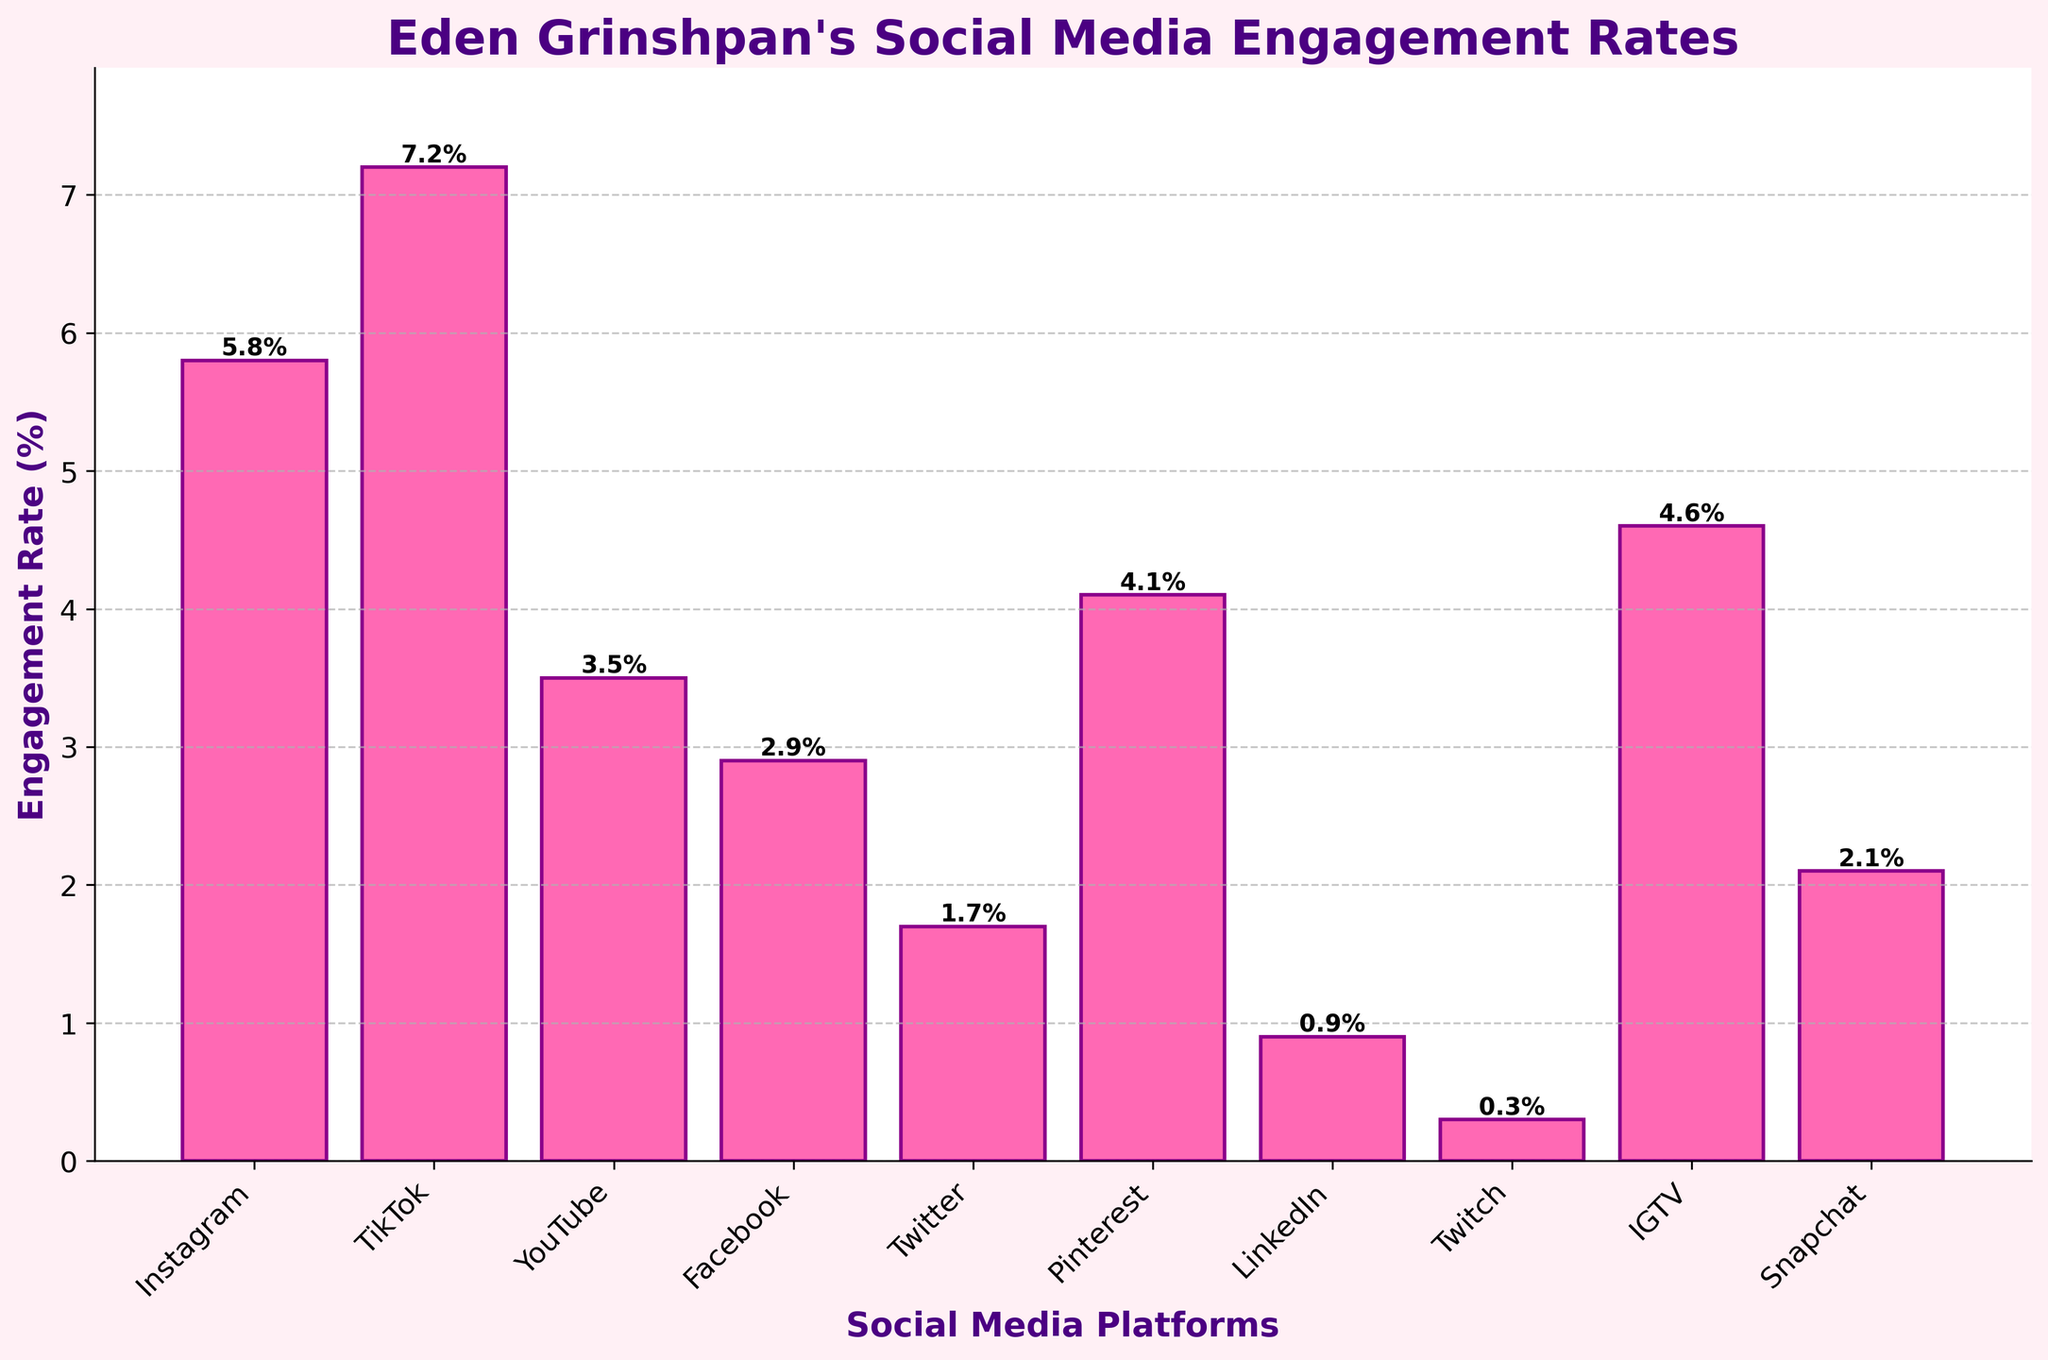What platform has the highest engagement rate? Look at the bar chart and identify the tallest bar, which represents the highest engagement rate.
Answer: TikTok Which platform has the lowest engagement rate? Look at the shortest bar in the bar chart to determine the platform with the lowest engagement rate.
Answer: Twitch What's the difference in engagement rate between Instagram and TikTok? Identify the engagement rates of Instagram (5.8%) and TikTok (7.2%), then subtract the smaller rate from the larger rate: 7.2 - 5.8.
Answer: 1.4% Which platform has a higher engagement rate, YouTube or Facebook? Compare the heights of the bars for YouTube (3.5%) and Facebook (2.9%).
Answer: YouTube What is the average engagement rate across all platforms? Sum all the engagement rates (5.8 + 7.2 + 3.5 + 2.9 + 1.7 + 4.1 + 0.9 + 0.3 + 4.6 + 2.1 = 33.1) and divide by the number of platforms (10): 33.1/10.
Answer: 3.31% Which platform has an engagement rate closest to 4%? Identify the bar closest to the 4% mark. Pinterest (4.1%) is the closest.
Answer: Pinterest Which three platforms have the largest engagement rates? Identify the three tallest bars: TikTok, Instagram, and IGTV with engagement rates of 7.2%, 5.8%, and 4.6% respectively.
Answer: TikTok, Instagram, IGTV How much lower is the engagement rate for LinkedIn compared to Snapchat? Subtract LinkedIn's rate (0.9%) from Snapchat's rate (2.1%): 2.1 - 0.9.
Answer: 1.2% How many platforms have an engagement rate above 4%? Count the bars with heights greater than 4%. There are 4 platforms: Instagram, TikTok, Pinterest, and IGTV.
Answer: 4 